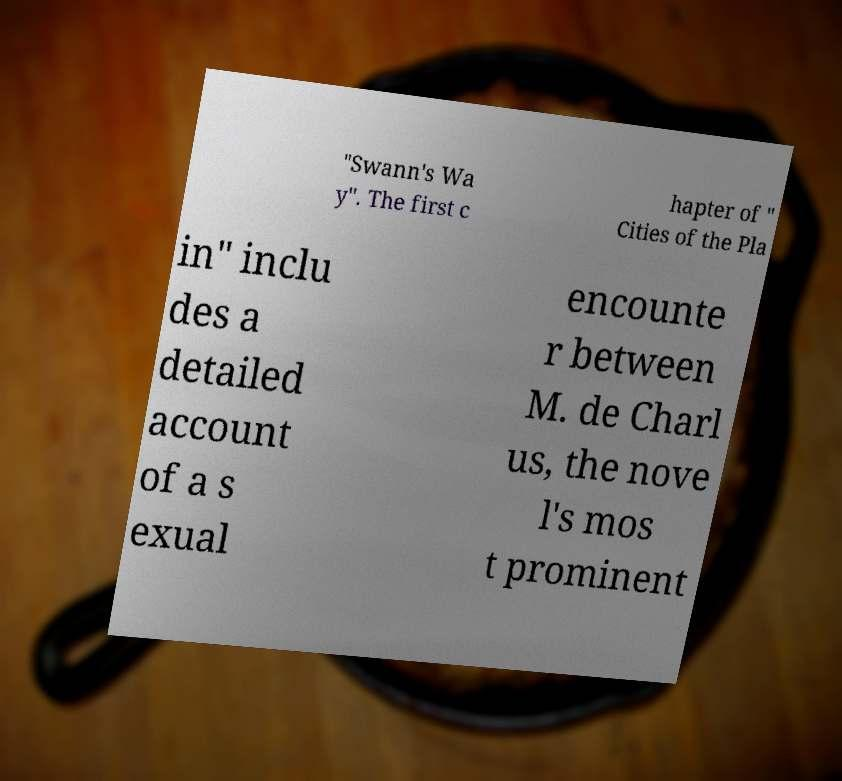There's text embedded in this image that I need extracted. Can you transcribe it verbatim? "Swann's Wa y". The first c hapter of " Cities of the Pla in" inclu des a detailed account of a s exual encounte r between M. de Charl us, the nove l's mos t prominent 